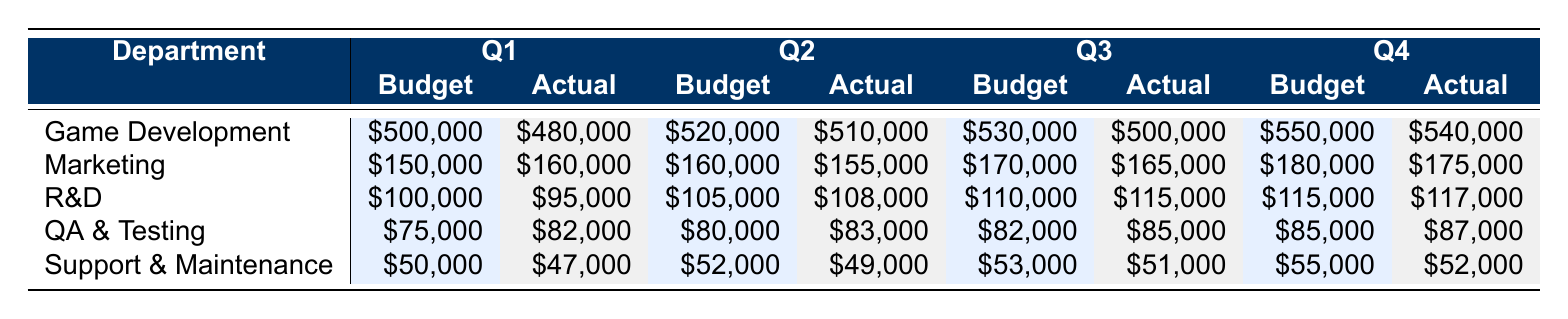What was the actual spend for Game Development in Q1? The table specifies that the actual spend for Game Development in Q1 is directly listed as 480,000.
Answer: 480,000 Which department had the highest actual spend in Q2? By looking at the actual spend for each department in Q2, Marketing spent 155,000, Game Development spent 510,000, R&D spent 108,000, QA & Testing spent 83,000, and Support & Maintenance spent 49,000. The highest is Game Development at 510,000.
Answer: Game Development What is the difference between the budget and actual spend for R&D in Q3? R&D's budget in Q3 is 110,000, and the actual spend is 115,000. The difference is calculated by subtracting the budget from the actual spend: 115,000 - 110,000 = 5,000.
Answer: 5,000 Did the actual spend for Marketing increase from Q1 to Q4? The actual spends for Marketing are 160,000 in Q1 and 175,000 in Q4. A simple comparison shows that 175,000 is greater than 160,000, indicating an increase.
Answer: Yes What is the total actual spend across all departments for Q1? To find the total actual spend for Q1, we add the actual spends from all departments: 480,000 (Game Development) + 160,000 (Marketing) + 95,000 (R&D) + 82,000 (QA & Testing) + 47,000 (Support & Maintenance) = 864,000.
Answer: 864,000 Was the actual spend for QA & Testing higher in Q3 than in Q2? In Q3, the actual spend for QA & Testing is 85,000, while in Q2 it is 83,000. Since 85,000 is greater than 83,000, we can conclude that the actual spend increased.
Answer: Yes What was the average budget for game development across all quarters? The budgets for Game Development across the four quarters are 500,000, 520,000, 530,000, and 550,000. The sum is 2,100,000 and dividing by the number of quarters (4) gives an average of 525,000.
Answer: 525,000 How much did Support & Maintenance overspend compared to its budget in Q4? The budget for Support & Maintenance in Q4 is 55,000 and the actual spend is 52,000. Therefore, it did not overspend; instead, it spent 3,000 less than the budget.
Answer: No What was the total budget allocated for Marketing in 2023? The budgets for Marketing across the four quarters are 150,000 (Q1), 160,000 (Q2), 170,000 (Q3), and 180,000 (Q4). Adding these gives a total budget of 660,000.
Answer: 660,000 